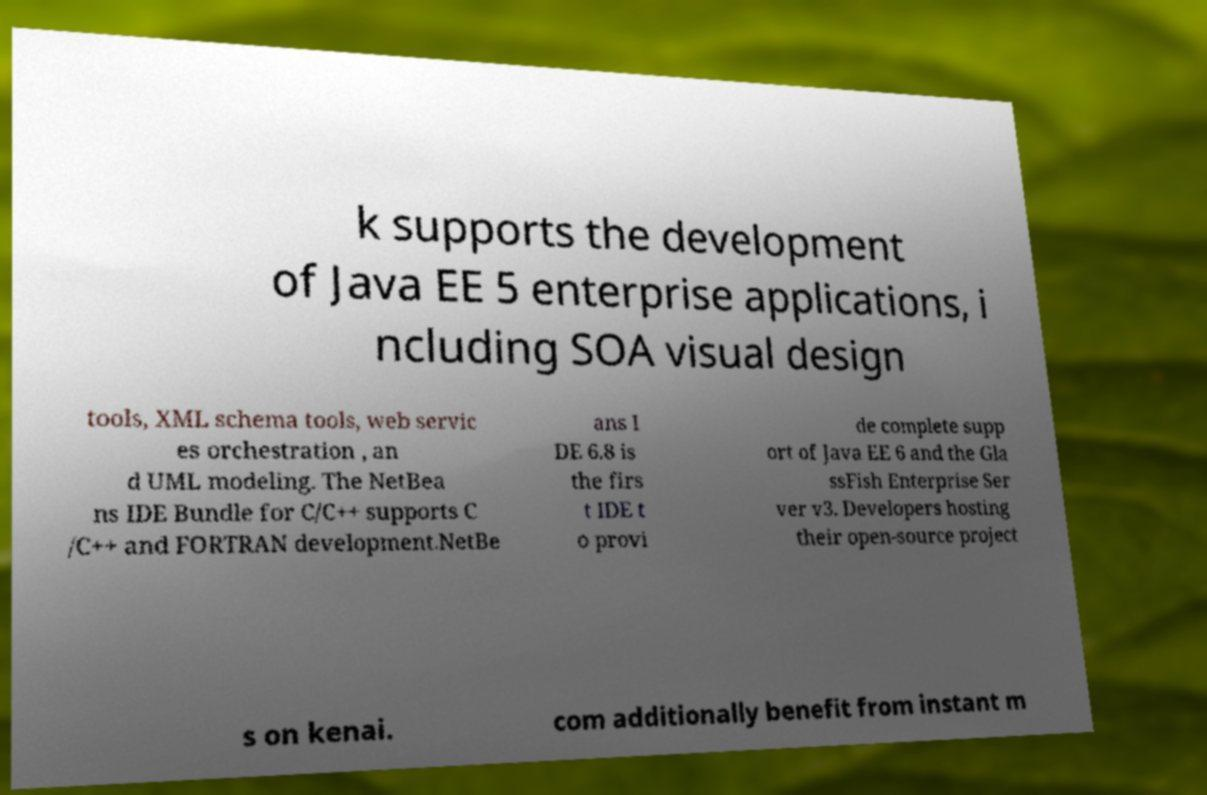Can you accurately transcribe the text from the provided image for me? k supports the development of Java EE 5 enterprise applications, i ncluding SOA visual design tools, XML schema tools, web servic es orchestration , an d UML modeling. The NetBea ns IDE Bundle for C/C++ supports C /C++ and FORTRAN development.NetBe ans I DE 6.8 is the firs t IDE t o provi de complete supp ort of Java EE 6 and the Gla ssFish Enterprise Ser ver v3. Developers hosting their open-source project s on kenai. com additionally benefit from instant m 